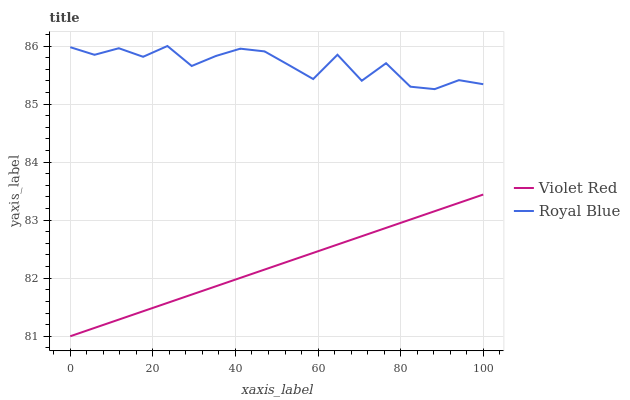Does Violet Red have the minimum area under the curve?
Answer yes or no. Yes. Does Royal Blue have the maximum area under the curve?
Answer yes or no. Yes. Does Violet Red have the maximum area under the curve?
Answer yes or no. No. Is Violet Red the smoothest?
Answer yes or no. Yes. Is Royal Blue the roughest?
Answer yes or no. Yes. Is Violet Red the roughest?
Answer yes or no. No. Does Violet Red have the lowest value?
Answer yes or no. Yes. Does Royal Blue have the highest value?
Answer yes or no. Yes. Does Violet Red have the highest value?
Answer yes or no. No. Is Violet Red less than Royal Blue?
Answer yes or no. Yes. Is Royal Blue greater than Violet Red?
Answer yes or no. Yes. Does Violet Red intersect Royal Blue?
Answer yes or no. No. 